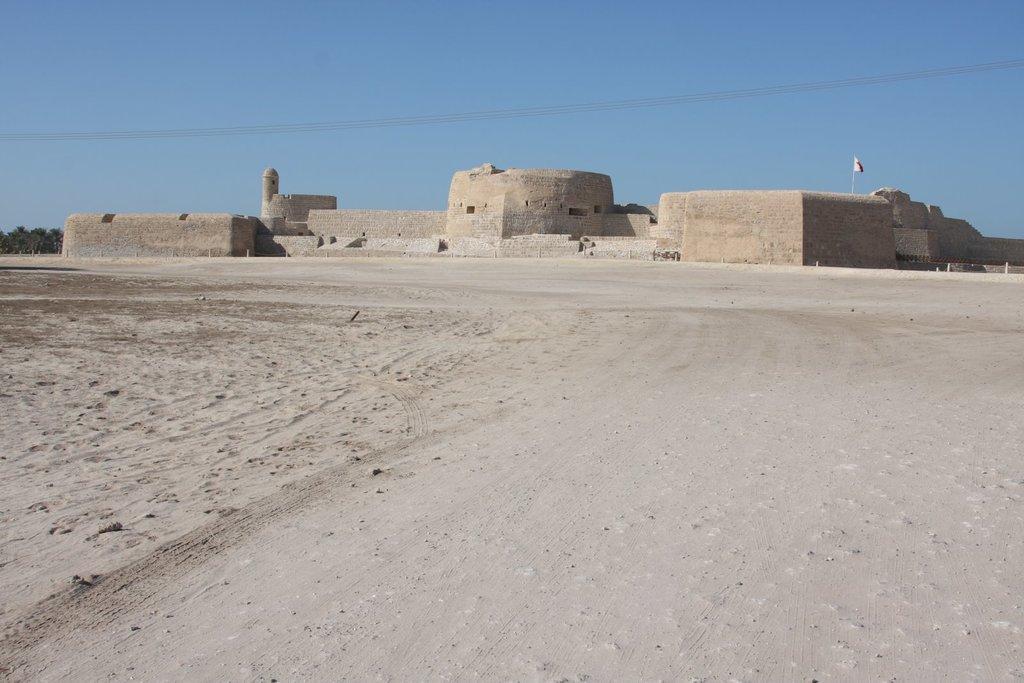Please provide a concise description of this image. In this picture i can see the monument. On the right there is a flag on the roof of the monument. On the left i can see the sand and many trees. At the top there is a sky. Here i can see the electric wires. 